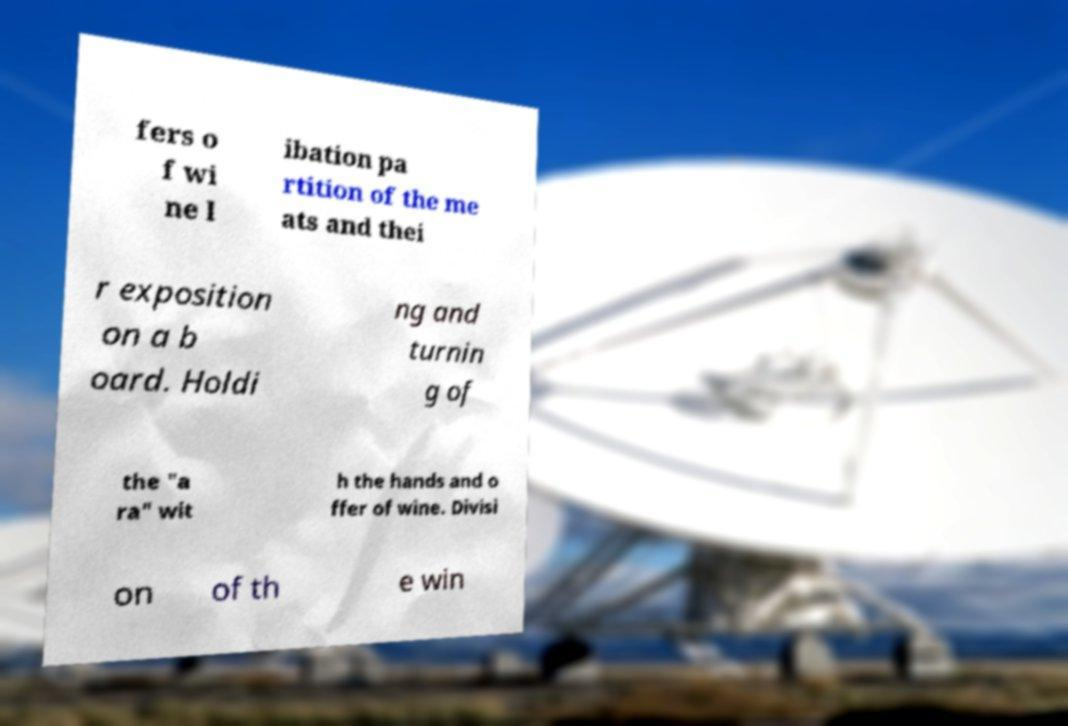Could you assist in decoding the text presented in this image and type it out clearly? fers o f wi ne l ibation pa rtition of the me ats and thei r exposition on a b oard. Holdi ng and turnin g of the "a ra" wit h the hands and o ffer of wine. Divisi on of th e win 